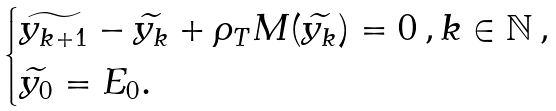Convert formula to latex. <formula><loc_0><loc_0><loc_500><loc_500>\begin{cases} \widetilde { y _ { k + 1 } } - \widetilde { y _ { k } } + \rho _ { T } M ( \widetilde { y _ { k } } ) = 0 \, , k \in \mathbb { N } \, , \\ \widetilde { y _ { 0 } } = E _ { 0 } . \end{cases}</formula> 